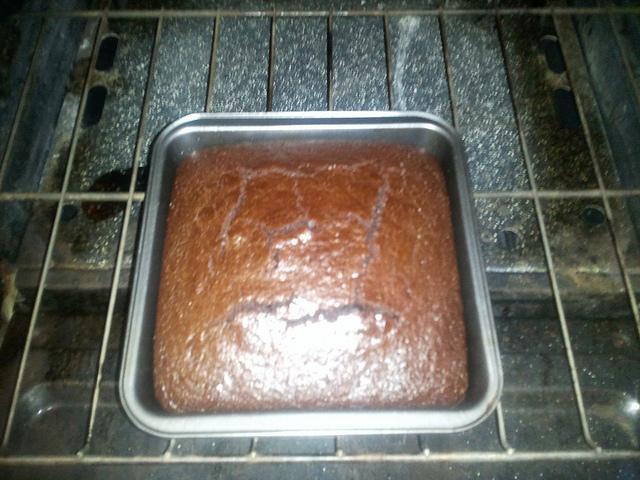Verify the accuracy of this image caption: "The oven is surrounding the cake.".
Answer yes or no. Yes. Is "The cake is outside the oven." an appropriate description for the image?
Answer yes or no. No. Does the image validate the caption "The oven contains the cake."?
Answer yes or no. Yes. Is "The cake is in the oven." an appropriate description for the image?
Answer yes or no. Yes. Is "The oven is above the cake." an appropriate description for the image?
Answer yes or no. No. 